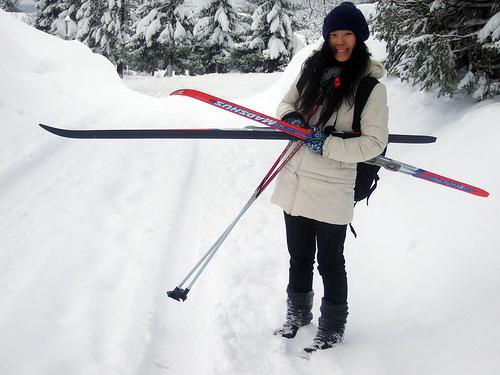Question: how is the woman's expression?
Choices:
A. She is sad.
B. She is smiling.
C. She is excited.
D. She is crying.
Answer with the letter. Answer: B Question: where was this picture taken?
Choices:
A. In a theater.
B. A ski slope.
C. In a park.
D. In a hotel.
Answer with the letter. Answer: B Question: what color is the woman's jacket?
Choices:
A. Cream.
B. Orange.
C. Red.
D. Blue.
Answer with the letter. Answer: A Question: who is in the picture?
Choices:
A. A cat.
B. A baby.
C. Your friend.
D. A woman.
Answer with the letter. Answer: D Question: what is the woman holding?
Choices:
A. A baby.
B. A gallon of milk.
C. Skis.
D. A sweater.
Answer with the letter. Answer: C 